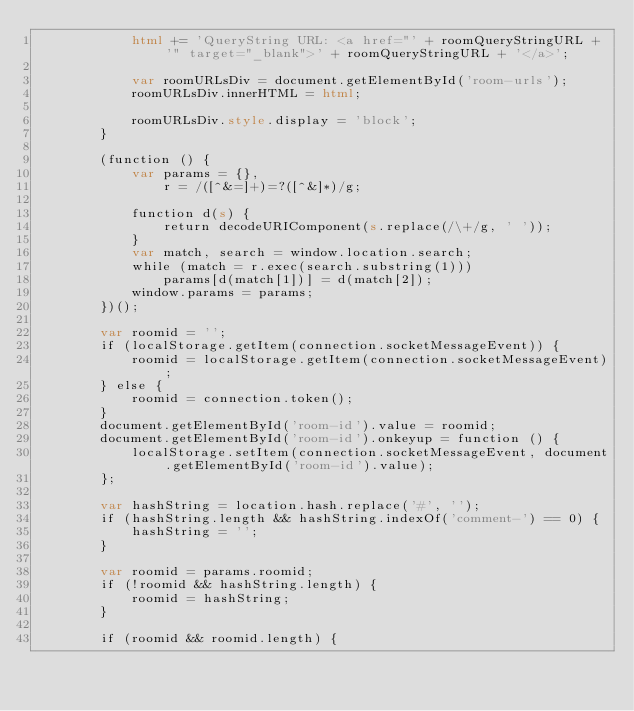<code> <loc_0><loc_0><loc_500><loc_500><_HTML_>            html += 'QueryString URL: <a href="' + roomQueryStringURL + '" target="_blank">' + roomQueryStringURL + '</a>';

            var roomURLsDiv = document.getElementById('room-urls');
            roomURLsDiv.innerHTML = html;

            roomURLsDiv.style.display = 'block';
        }

        (function () {
            var params = {},
                r = /([^&=]+)=?([^&]*)/g;

            function d(s) {
                return decodeURIComponent(s.replace(/\+/g, ' '));
            }
            var match, search = window.location.search;
            while (match = r.exec(search.substring(1)))
                params[d(match[1])] = d(match[2]);
            window.params = params;
        })();

        var roomid = '';
        if (localStorage.getItem(connection.socketMessageEvent)) {
            roomid = localStorage.getItem(connection.socketMessageEvent);
        } else {
            roomid = connection.token();
        }
        document.getElementById('room-id').value = roomid;
        document.getElementById('room-id').onkeyup = function () {
            localStorage.setItem(connection.socketMessageEvent, document.getElementById('room-id').value);
        };

        var hashString = location.hash.replace('#', '');
        if (hashString.length && hashString.indexOf('comment-') == 0) {
            hashString = '';
        }

        var roomid = params.roomid;
        if (!roomid && hashString.length) {
            roomid = hashString;
        }

        if (roomid && roomid.length) {</code> 